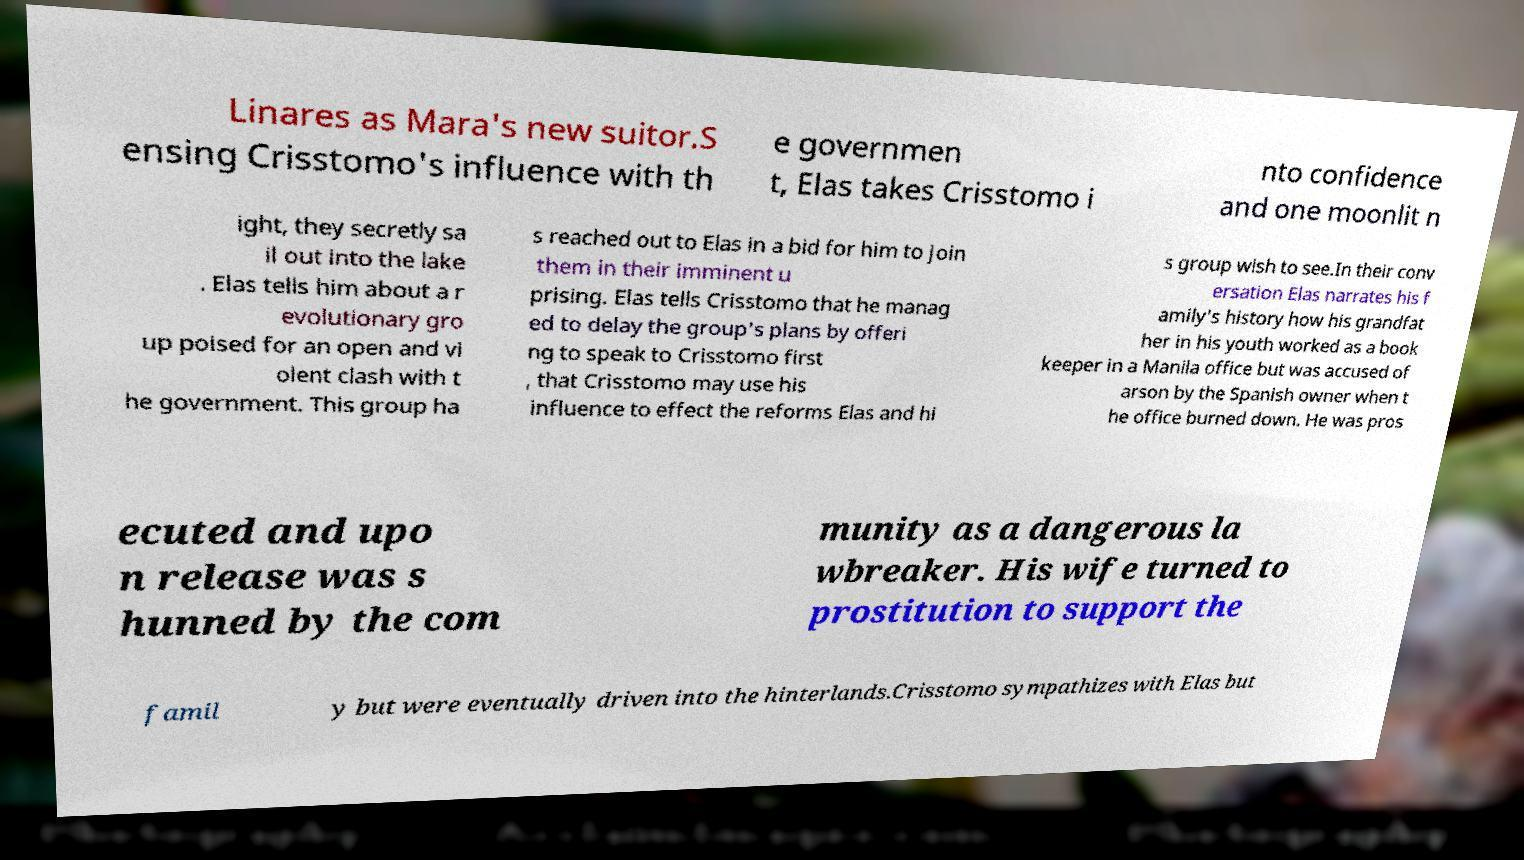For documentation purposes, I need the text within this image transcribed. Could you provide that? Linares as Mara's new suitor.S ensing Crisstomo's influence with th e governmen t, Elas takes Crisstomo i nto confidence and one moonlit n ight, they secretly sa il out into the lake . Elas tells him about a r evolutionary gro up poised for an open and vi olent clash with t he government. This group ha s reached out to Elas in a bid for him to join them in their imminent u prising. Elas tells Crisstomo that he manag ed to delay the group's plans by offeri ng to speak to Crisstomo first , that Crisstomo may use his influence to effect the reforms Elas and hi s group wish to see.In their conv ersation Elas narrates his f amily's history how his grandfat her in his youth worked as a book keeper in a Manila office but was accused of arson by the Spanish owner when t he office burned down. He was pros ecuted and upo n release was s hunned by the com munity as a dangerous la wbreaker. His wife turned to prostitution to support the famil y but were eventually driven into the hinterlands.Crisstomo sympathizes with Elas but 